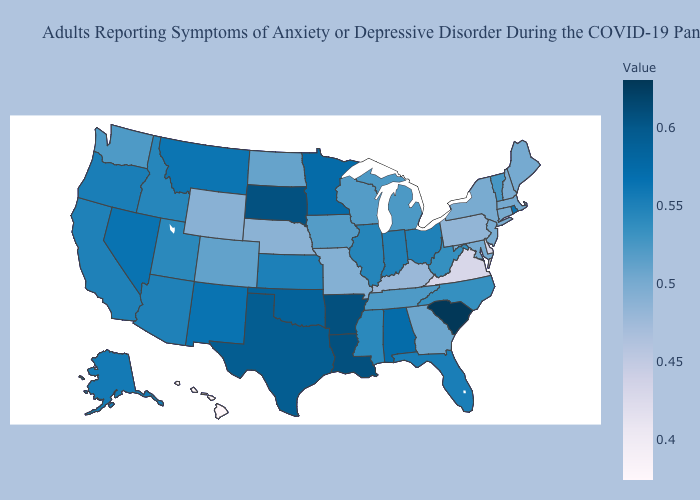Does Connecticut have the lowest value in the USA?
Quick response, please. No. Does New Mexico have a lower value than South Carolina?
Answer briefly. Yes. Is the legend a continuous bar?
Be succinct. Yes. 